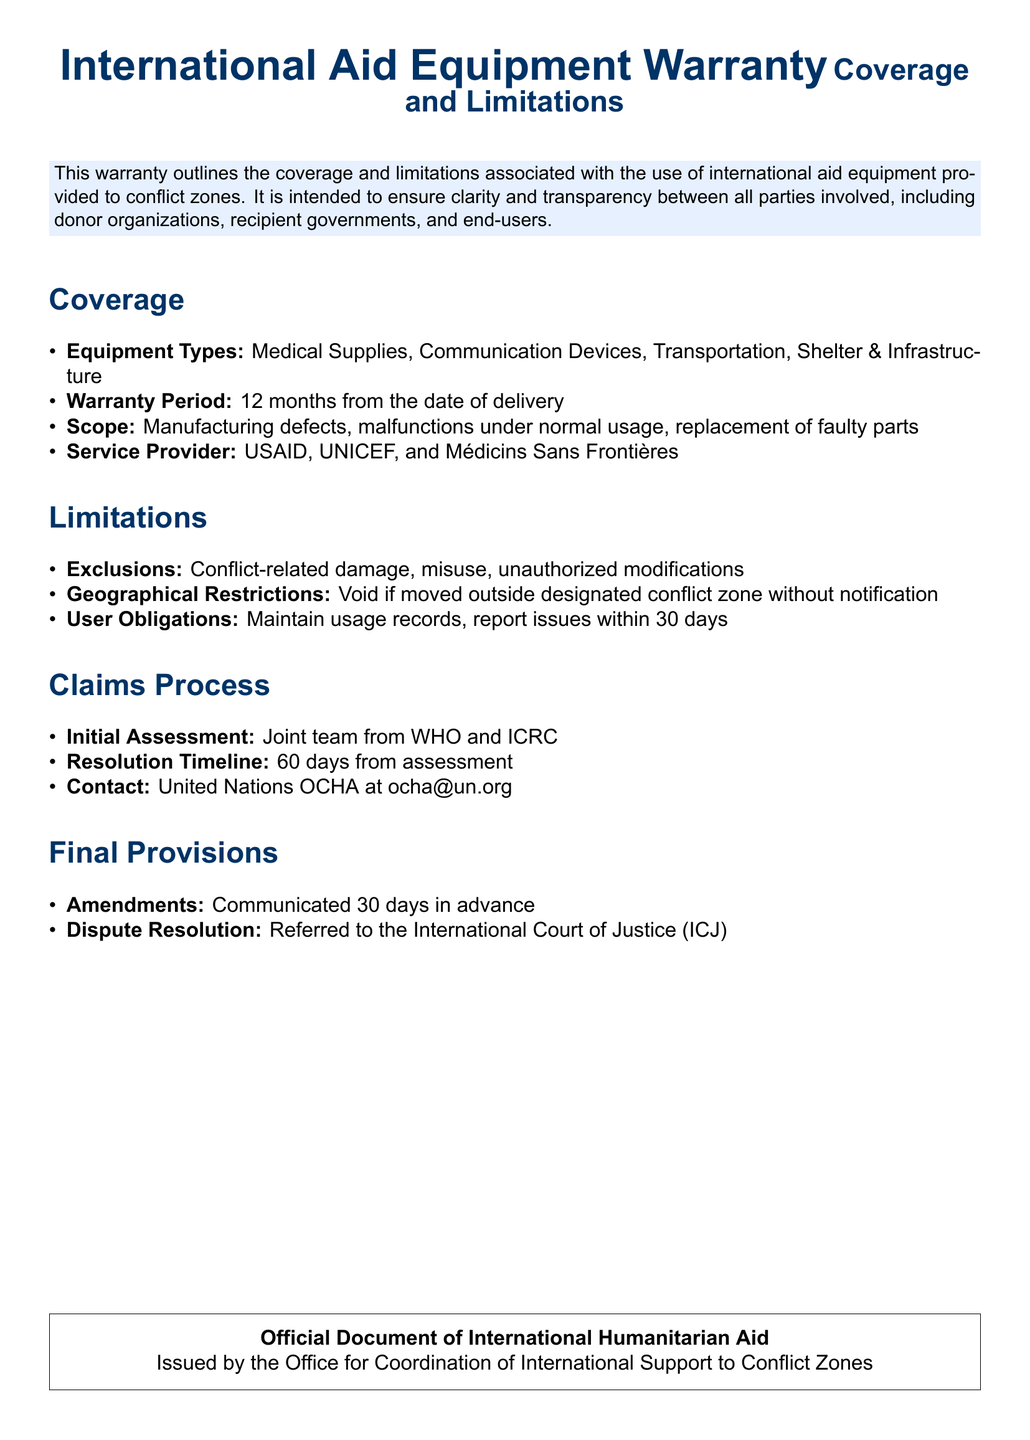what is the warranty period for equipment? The warranty period is stated in the document as being effective for 12 months from the date of delivery.
Answer: 12 months which organizations are service providers for the warranty? The document lists USAID, UNICEF, and Médicins Sans Frontières as service providers.
Answer: USAID, UNICEF, and Médicins Sans Frontières what types of equipment are covered under this warranty? The warranty specifically covers Medical Supplies, Communication Devices, Transportation, and Shelter & Infrastructure.
Answer: Medical Supplies, Communication Devices, Transportation, Shelter & Infrastructure what is the timeframe to report issues after detecting them? The document requires issues to be reported within 30 days of detection.
Answer: 30 days which entity is responsible for the initial assessment of claims? The document specifies that the initial assessment will be carried out by a joint team from WHO and ICRC.
Answer: WHO and ICRC what exclusions are mentioned in the warranty? The document lists exclusions such as conflict-related damage, misuse, and unauthorized modifications.
Answer: Conflict-related damage, misuse, unauthorized modifications where should claims be directed? The document provides a contact for claims, which is United Nations OCHA at ocha@un.org.
Answer: United Nations OCHA at ocha@un.org what is the resolution timeline for claims? The resolution timeline specified in the document is 60 days from assessment.
Answer: 60 days what is the geographical restriction indicated in the warranty? The document states that the warranty is void if equipment is moved outside the designated conflict zone without notification.
Answer: Void if moved outside designated conflict zone without notification 